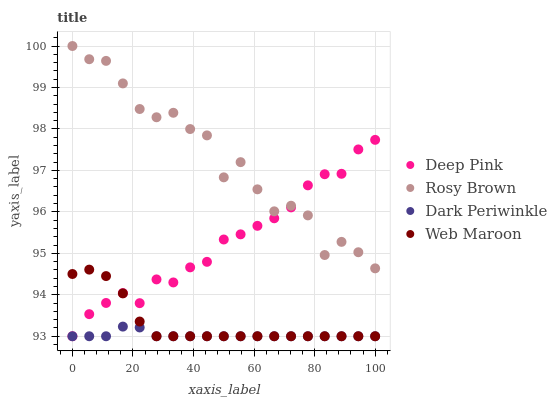Does Dark Periwinkle have the minimum area under the curve?
Answer yes or no. Yes. Does Rosy Brown have the maximum area under the curve?
Answer yes or no. Yes. Does Deep Pink have the minimum area under the curve?
Answer yes or no. No. Does Deep Pink have the maximum area under the curve?
Answer yes or no. No. Is Dark Periwinkle the smoothest?
Answer yes or no. Yes. Is Rosy Brown the roughest?
Answer yes or no. Yes. Is Deep Pink the smoothest?
Answer yes or no. No. Is Deep Pink the roughest?
Answer yes or no. No. Does Deep Pink have the lowest value?
Answer yes or no. Yes. Does Rosy Brown have the highest value?
Answer yes or no. Yes. Does Deep Pink have the highest value?
Answer yes or no. No. Is Web Maroon less than Rosy Brown?
Answer yes or no. Yes. Is Rosy Brown greater than Dark Periwinkle?
Answer yes or no. Yes. Does Dark Periwinkle intersect Web Maroon?
Answer yes or no. Yes. Is Dark Periwinkle less than Web Maroon?
Answer yes or no. No. Is Dark Periwinkle greater than Web Maroon?
Answer yes or no. No. Does Web Maroon intersect Rosy Brown?
Answer yes or no. No. 